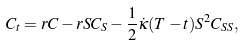Convert formula to latex. <formula><loc_0><loc_0><loc_500><loc_500>C _ { t } = r C - r S C _ { S } - \frac { 1 } { 2 } \dot { \kappa } ( T - t ) S ^ { 2 } C _ { S S } ,</formula> 